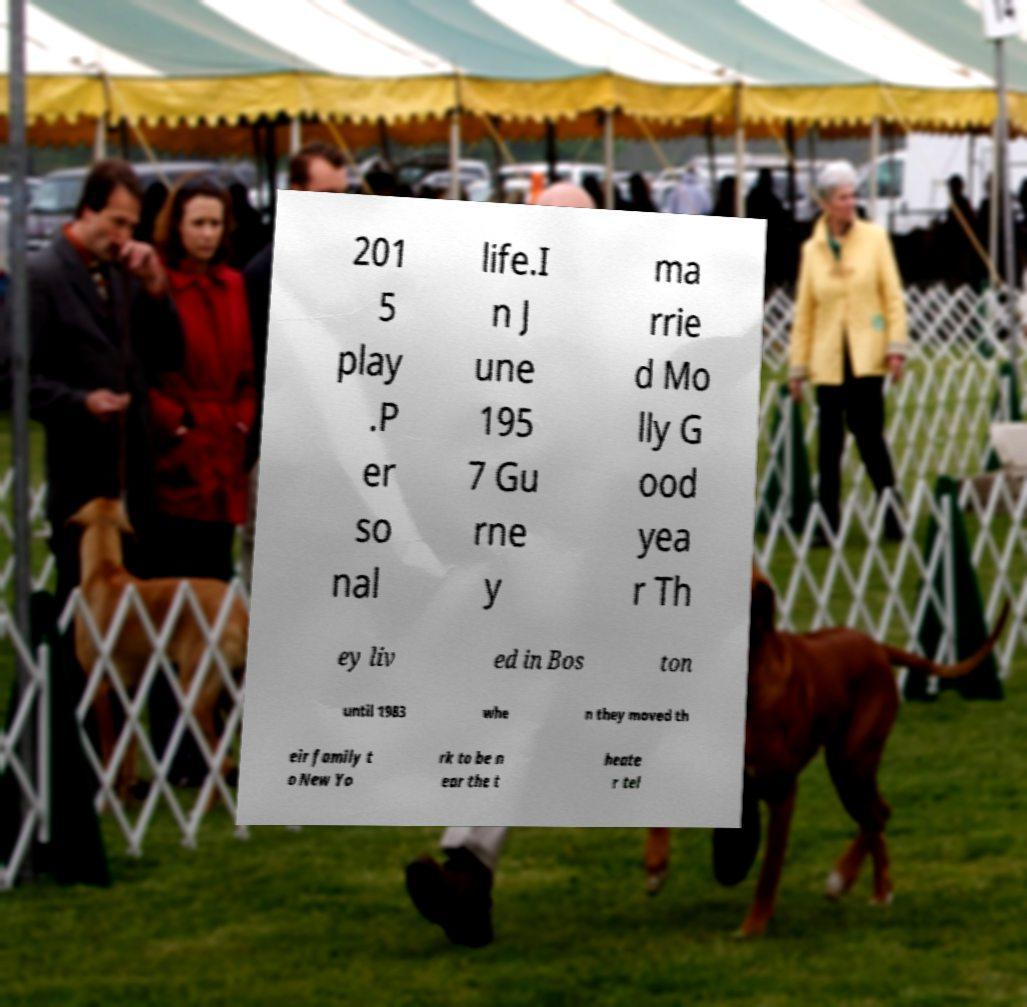Please identify and transcribe the text found in this image. 201 5 play .P er so nal life.I n J une 195 7 Gu rne y ma rrie d Mo lly G ood yea r Th ey liv ed in Bos ton until 1983 whe n they moved th eir family t o New Yo rk to be n ear the t heate r tel 